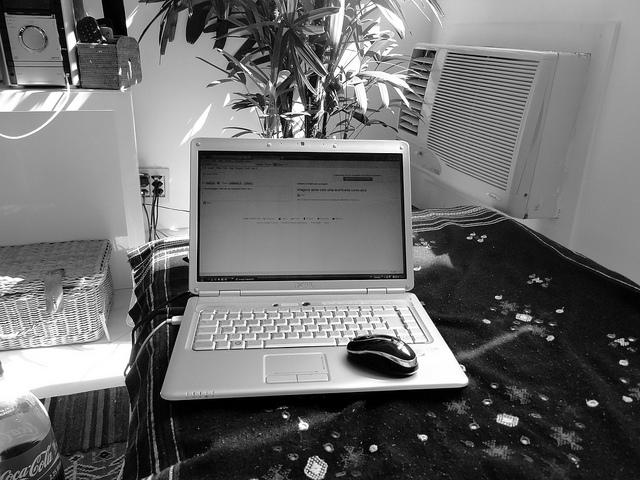Why would someone sit at this area? work 